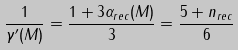<formula> <loc_0><loc_0><loc_500><loc_500>\frac { 1 } { \gamma ^ { \prime } ( M ) } = \frac { 1 + 3 \alpha _ { r e c } ( M ) } { 3 } = \frac { 5 + n _ { r e c } } { 6 }</formula> 